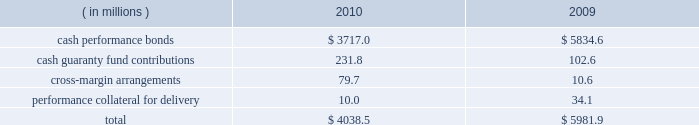Anticipated or possible short-term cash needs , prevailing interest rates , our investment policy and alternative investment choices .
A majority of our cash and cash equivalents balance is invested in money market mutual funds that invest only in u.s .
Treasury securities or u.s .
Government agency securities .
Our exposure to risk is minimal given the nature of the investments .
Our practice is to have our pension plan 100% ( 100 % ) funded at each year end on a projected benefit obligation basis , while also satisfying any minimum required contribution and obtaining the maximum tax deduction .
Based on our actuarial projections , we estimate that a $ 14.1 million contribution in 2011 will allow us to meet our funding goal .
However , the amount of the actual contribution is contingent on the actual rate of return on our plan assets during 2011 and the december 31 , 2011 discount rate .
Net current deferred tax assets of $ 18.3 million and $ 23.8 million are included in other current assets at december 31 , 2010 and 2009 , respectively .
Total net current deferred tax assets include unrealized losses , stock- based compensation and accrued expenses .
Net long-term deferred tax liabilities were $ 7.8 billion and $ 7.6 billion at december 31 , 2010 and 2009 , respectively .
Net deferred tax liabilities are principally the result of purchase accounting for intangible assets in our various mergers including cbot holdings and nymex holdings .
We have a long-term deferred tax asset of $ 145.7 million included within our domestic long-term deferred tax liability .
This deferred tax asset is for an unrealized capital loss incurred in brazil related to our investment in bm&fbovespa .
As of december 31 , 2010 , we do not believe that we currently meet the more-likely-than-not threshold that would allow us to fully realize the value of the unrealized capital loss .
As a result , a partial valuation allowance of $ 64.4 million has been provided for the amount of the unrealized capital loss that exceeds potential capital gains that could be used to offset the capital loss in future periods .
We also have a long-term deferred tax asset related to brazilian taxes of $ 125.3 million for an unrealized capital loss incurred in brazil related to our investment in bm&fbovespa .
A full valuation allowance of $ 125.3 million has been provided because we do not believe that we currently meet the more-likely-than-not threshold that would allow us to realize the value of the unrealized capital loss in brazil in the future .
Valuation allowances of $ 49.4 million have also been provided for additional unrealized capital losses on various other investments .
Net long-term deferred tax assets also include a $ 19.3 million deferred tax asset for foreign net operating losses related to swapstream .
Our assessment at december 31 , 2010 was that we did not currently meet the more-likely- than-not threshold that would allow us to realize the value of acquired and accumulated foreign net operating losses in the future .
As a result , the $ 19.3 million deferred tax assets arising from these net operating losses have been fully reserved .
Each clearing firm is required to deposit and maintain specified performance bond collateral .
Performance bond requirements are determined by parameters established by the risk management department of the clearing house and may fluctuate over time .
We accept a variety of collateral to satisfy performance bond requirements .
Cash performance bonds and guaranty fund contributions are included in our consolidated balance sheets .
Clearing firm deposits , other than those retained in the form of cash , are not included in our consolidated balance sheets .
The balances in cash performance bonds and guaranty fund contributions may fluctuate significantly over time .
Cash performance bonds and guaranty fund contributions consisted of the following at december 31: .

In 2010 what was the percent of the cash performance bonds and guaranty fund contributions from cash performance bonds? 
Computations: (3717.0 / 4038.5)
Answer: 0.92039. 